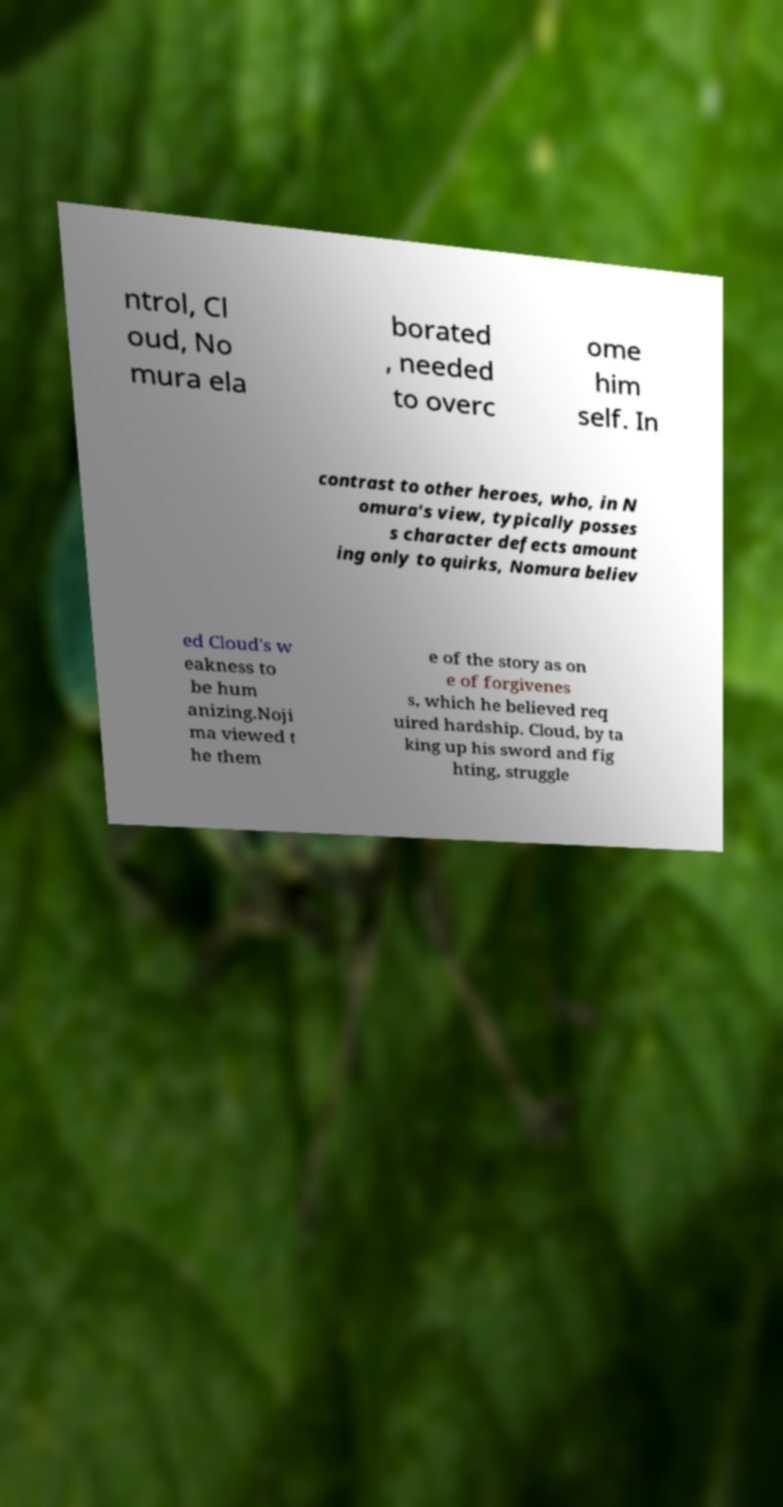Please identify and transcribe the text found in this image. ntrol, Cl oud, No mura ela borated , needed to overc ome him self. In contrast to other heroes, who, in N omura's view, typically posses s character defects amount ing only to quirks, Nomura believ ed Cloud's w eakness to be hum anizing.Noji ma viewed t he them e of the story as on e of forgivenes s, which he believed req uired hardship. Cloud, by ta king up his sword and fig hting, struggle 